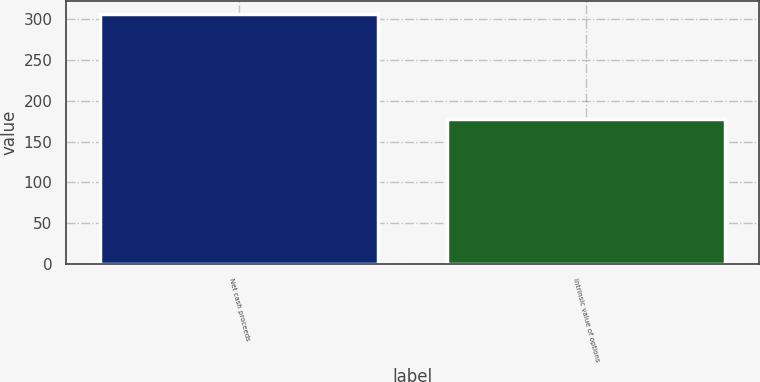<chart> <loc_0><loc_0><loc_500><loc_500><bar_chart><fcel>Net cash proceeds<fcel>Intrinsic value of options<nl><fcel>307<fcel>177.3<nl></chart> 